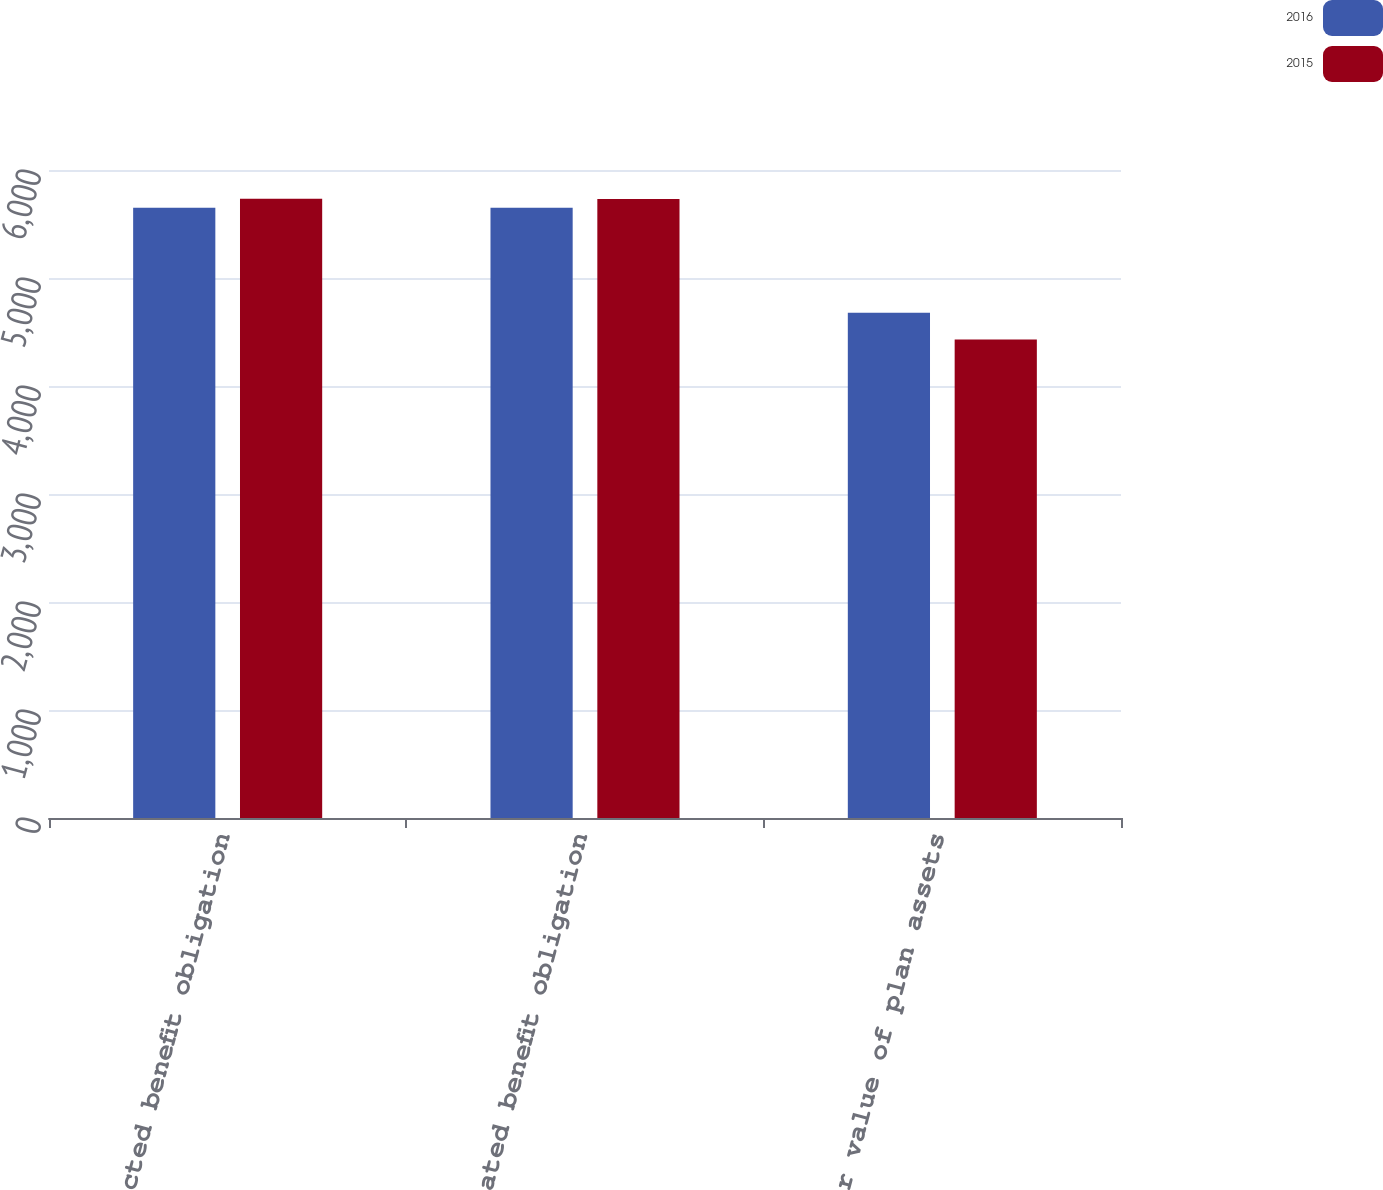<chart> <loc_0><loc_0><loc_500><loc_500><stacked_bar_chart><ecel><fcel>Projected benefit obligation<fcel>Accumulated benefit obligation<fcel>Fair value of plan assets<nl><fcel>2016<fcel>5650<fcel>5650<fcel>4678<nl><fcel>2015<fcel>5734<fcel>5732<fcel>4430<nl></chart> 